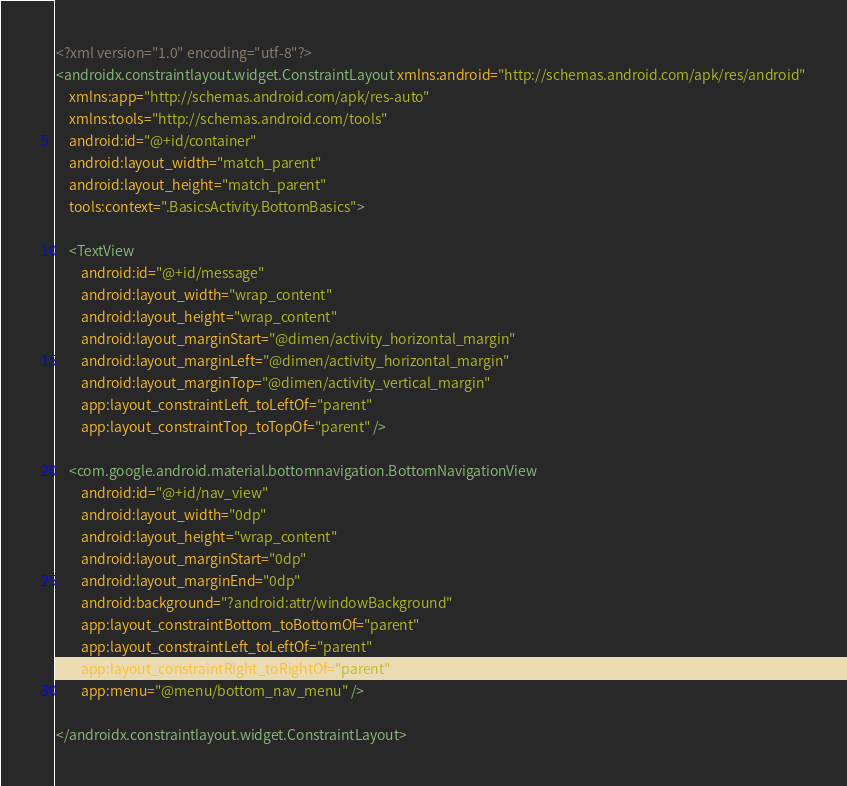Convert code to text. <code><loc_0><loc_0><loc_500><loc_500><_XML_><?xml version="1.0" encoding="utf-8"?>
<androidx.constraintlayout.widget.ConstraintLayout xmlns:android="http://schemas.android.com/apk/res/android"
    xmlns:app="http://schemas.android.com/apk/res-auto"
    xmlns:tools="http://schemas.android.com/tools"
    android:id="@+id/container"
    android:layout_width="match_parent"
    android:layout_height="match_parent"
    tools:context=".BasicsActivity.BottomBasics">

    <TextView
        android:id="@+id/message"
        android:layout_width="wrap_content"
        android:layout_height="wrap_content"
        android:layout_marginStart="@dimen/activity_horizontal_margin"
        android:layout_marginLeft="@dimen/activity_horizontal_margin"
        android:layout_marginTop="@dimen/activity_vertical_margin"
        app:layout_constraintLeft_toLeftOf="parent"
        app:layout_constraintTop_toTopOf="parent" />

    <com.google.android.material.bottomnavigation.BottomNavigationView
        android:id="@+id/nav_view"
        android:layout_width="0dp"
        android:layout_height="wrap_content"
        android:layout_marginStart="0dp"
        android:layout_marginEnd="0dp"
        android:background="?android:attr/windowBackground"
        app:layout_constraintBottom_toBottomOf="parent"
        app:layout_constraintLeft_toLeftOf="parent"
        app:layout_constraintRight_toRightOf="parent"
        app:menu="@menu/bottom_nav_menu" />

</androidx.constraintlayout.widget.ConstraintLayout></code> 